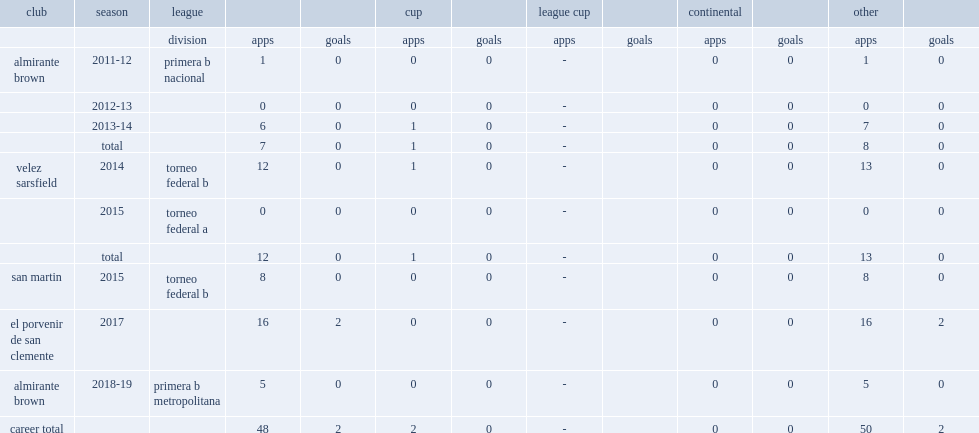What was the number of appearances made by arias for velez sarsfield in torneo federal b? 12.0. 